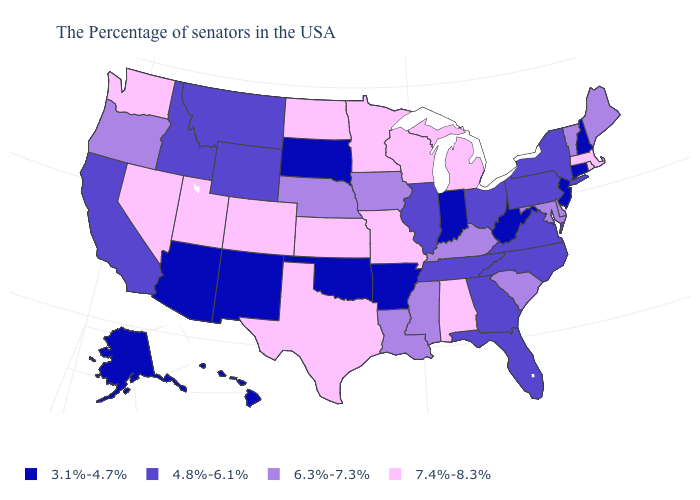Among the states that border California , which have the highest value?
Give a very brief answer. Nevada. What is the value of Pennsylvania?
Keep it brief. 4.8%-6.1%. Which states have the highest value in the USA?
Short answer required. Massachusetts, Rhode Island, Michigan, Alabama, Wisconsin, Missouri, Minnesota, Kansas, Texas, North Dakota, Colorado, Utah, Nevada, Washington. Does Ohio have a lower value than Michigan?
Keep it brief. Yes. Does West Virginia have the lowest value in the USA?
Quick response, please. Yes. Name the states that have a value in the range 7.4%-8.3%?
Concise answer only. Massachusetts, Rhode Island, Michigan, Alabama, Wisconsin, Missouri, Minnesota, Kansas, Texas, North Dakota, Colorado, Utah, Nevada, Washington. What is the lowest value in the South?
Short answer required. 3.1%-4.7%. Name the states that have a value in the range 7.4%-8.3%?
Answer briefly. Massachusetts, Rhode Island, Michigan, Alabama, Wisconsin, Missouri, Minnesota, Kansas, Texas, North Dakota, Colorado, Utah, Nevada, Washington. Does Rhode Island have a higher value than Arkansas?
Concise answer only. Yes. Does Maine have the lowest value in the USA?
Concise answer only. No. What is the lowest value in the Northeast?
Quick response, please. 3.1%-4.7%. What is the value of Utah?
Keep it brief. 7.4%-8.3%. Does Missouri have the lowest value in the MidWest?
Give a very brief answer. No. What is the highest value in the Northeast ?
Quick response, please. 7.4%-8.3%. Which states have the lowest value in the MidWest?
Quick response, please. Indiana, South Dakota. 